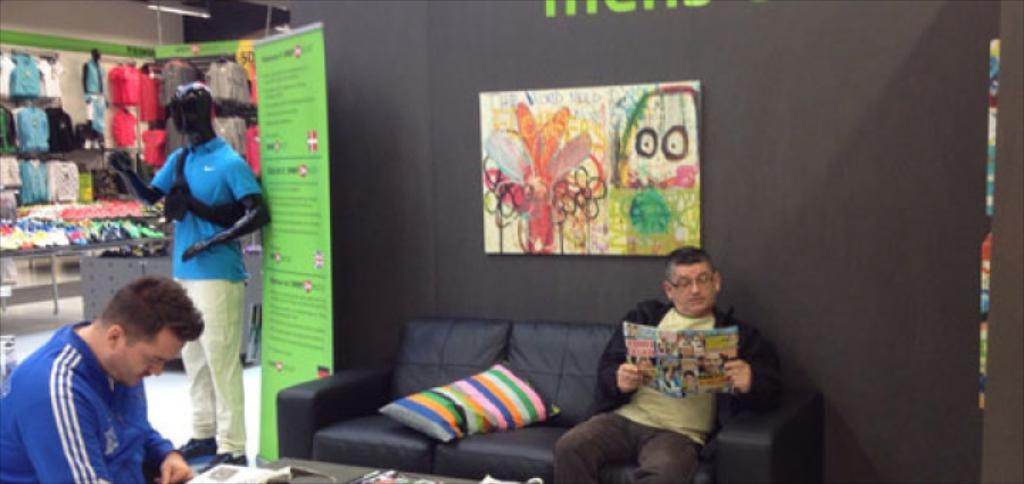What type of furniture is in the image? There is a couch with a pillow in the image. Who or what is sitting on the couch? A person is sitting on the couch. What is the person holding? The person is holding a paper. What can be seen hanging on the wall? There is a poster on the wall. What is the mannequin wearing? There are clothes visible in the image, which the mannequin is wearing. How many giraffes are standing on the couch in the image? There are no giraffes present in the image. What type of territory is being claimed by the person sitting on the couch? There is no indication of territory being claimed in the image. 